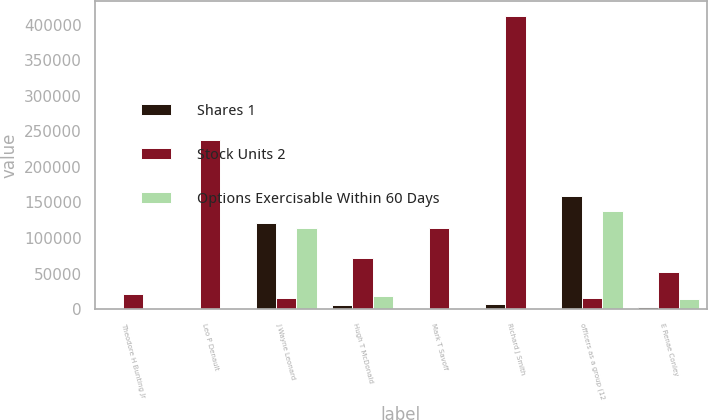Convert chart. <chart><loc_0><loc_0><loc_500><loc_500><stacked_bar_chart><ecel><fcel>Theodore H Bunting Jr<fcel>Leo P Denault<fcel>J Wayne Leonard<fcel>Hugh T McDonald<fcel>Mark T Savoff<fcel>Richard J Smith<fcel>officers as a group (12<fcel>E Renae Conley<nl><fcel>Shares 1<fcel>595<fcel>1531<fcel>120453<fcel>5742<fcel>661<fcel>7753<fcel>158529<fcel>2422<nl><fcel>Stock Units 2<fcel>20867<fcel>237357<fcel>16130.5<fcel>71554<fcel>114133<fcel>412472<fcel>16130.5<fcel>52163<nl><fcel>Options Exercisable Within 60 Days<fcel>128<fcel>753<fcel>113977<fcel>18554<fcel>231<fcel>1813<fcel>137597<fcel>13707<nl></chart> 